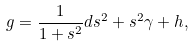Convert formula to latex. <formula><loc_0><loc_0><loc_500><loc_500>g = \frac { 1 } { 1 + s ^ { 2 } } d s ^ { 2 } + s ^ { 2 } \gamma + h ,</formula> 